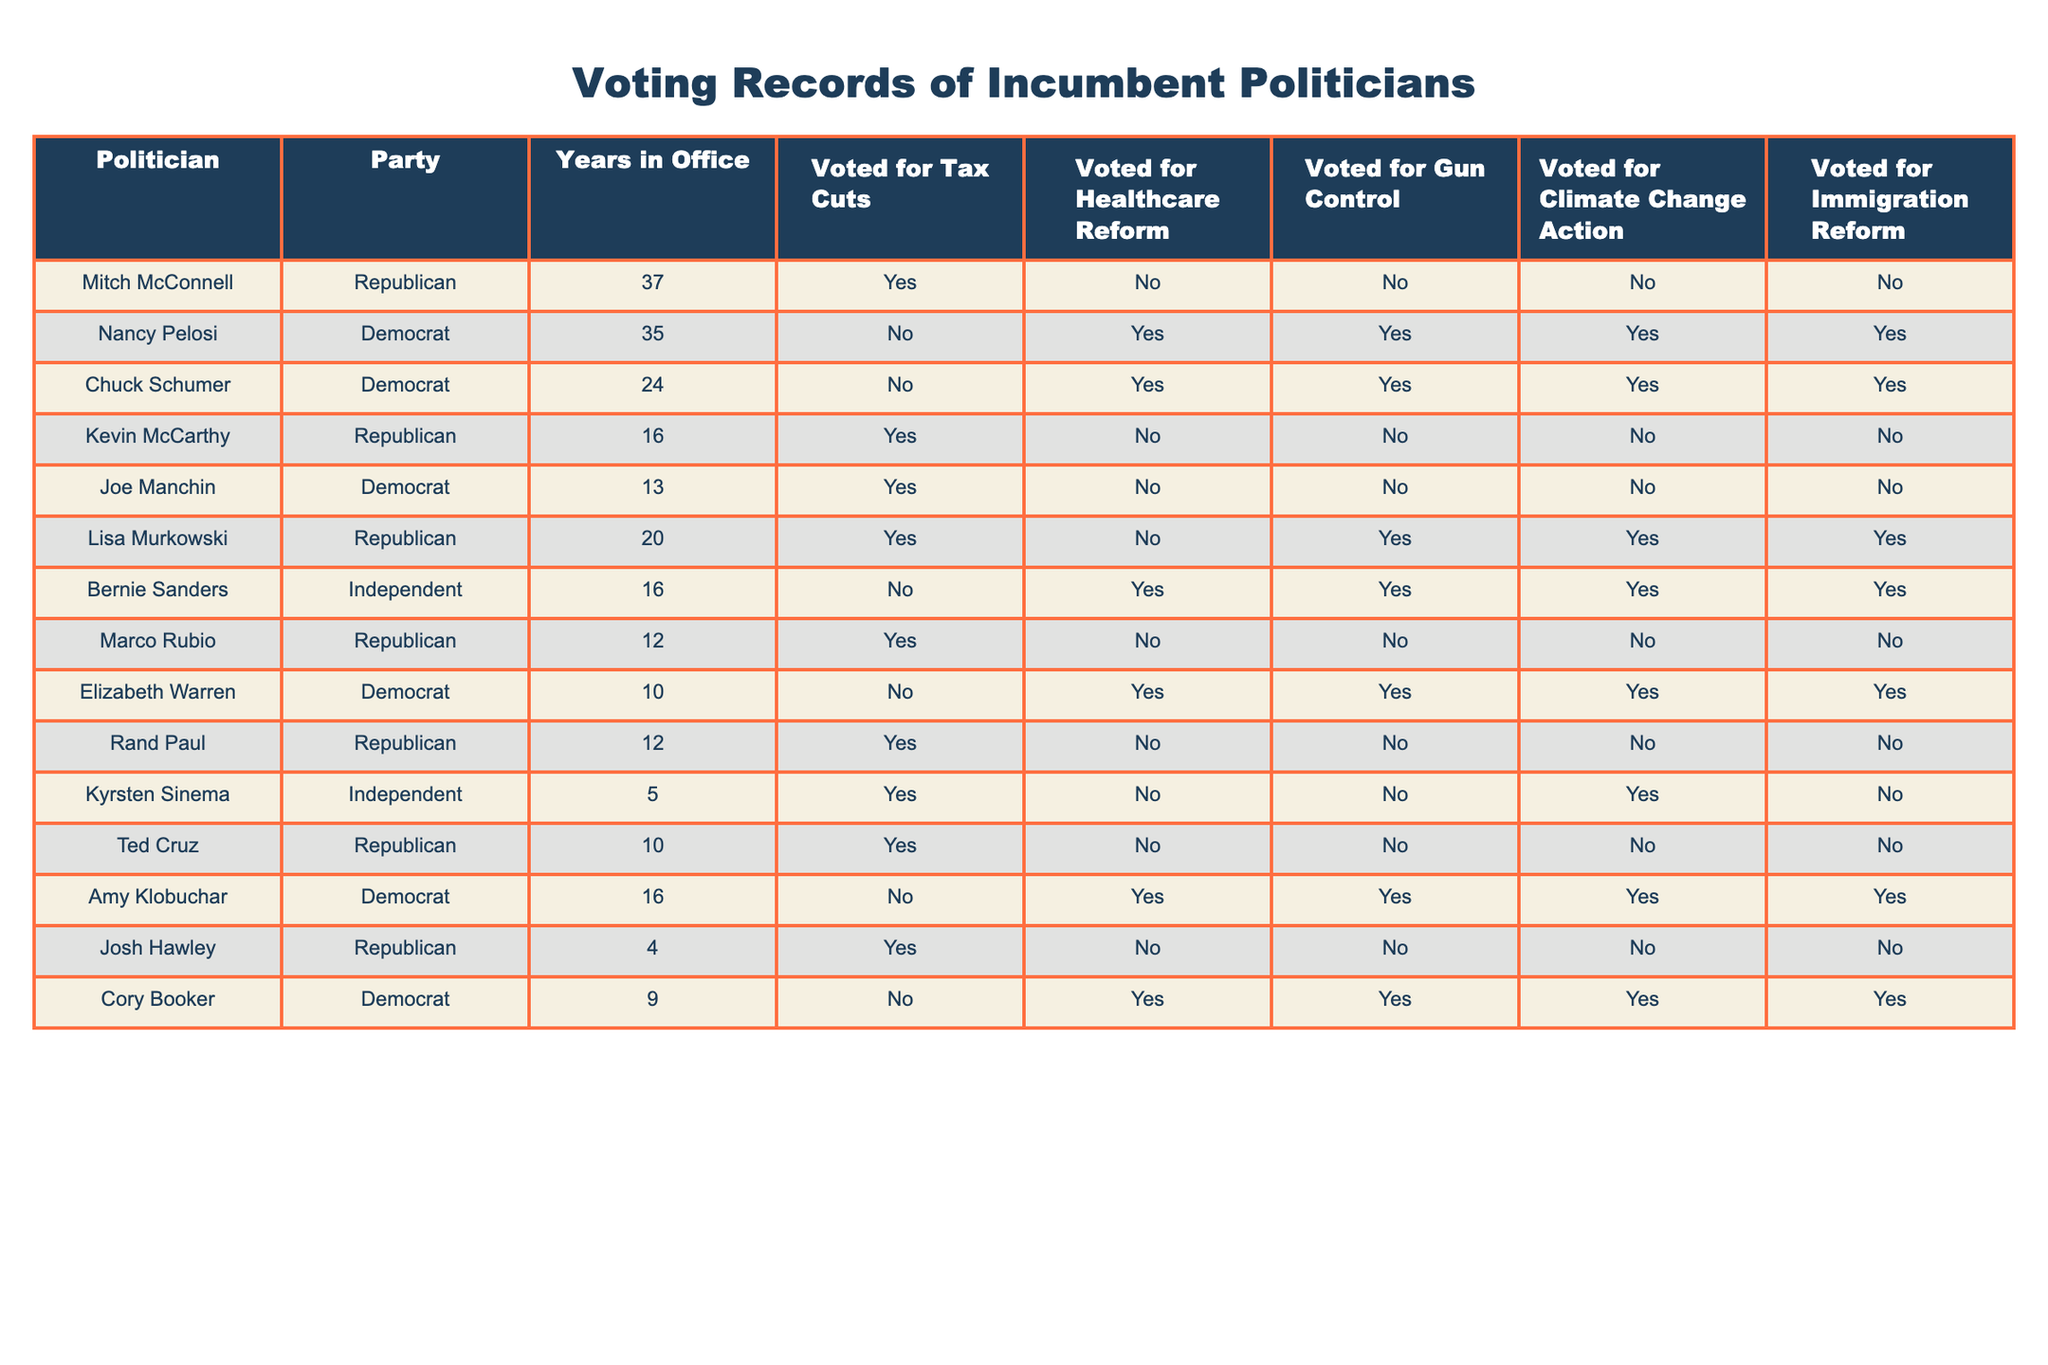What party does Bernie Sanders belong to? Bernie Sanders is listed in the "Party" column of the table. According to the data, he is categorized as an Independent.
Answer: Independent How many years has Nancy Pelosi been in office? By referring to the "Years in Office" column, we can see that Nancy Pelosi has served for 35 years.
Answer: 35 Did Joe Manchin vote for Healthcare Reform? Looking at the "Voted for Healthcare Reform" column for Joe Manchin, we see he voted "No."
Answer: No Which politician voted for Gun Control and Climate Change Action? We need to check the columns "Voted for Gun Control" and "Voted for Climate Change Action." By examining the table, we see that both Nancy Pelosi and Chuck Schumer voted "Yes" for both issues.
Answer: Nancy Pelosi and Chuck Schumer How many Republican politicians voted for Tax Cuts? From the "Voted for Tax Cuts" column, we count the number of "Yes" votes among Republican politicians: Mitch McConnell, Kevin McCarthy, Lisa Murkowski, Marco Rubio, Rand Paul, Ted Cruz, and Josh Hawley. This totals to 7 Republican politicians.
Answer: 7 Who has the longest time in office among Democrats? By checking the "Years in Office" column specifically for Democrats, Nancy Pelosi has served for 35 years, which is longer than any other Democrat in the table.
Answer: Nancy Pelosi Is there a politician who voted for both Gun Control and Immigration Reform? We analyze the "Voted for Gun Control" and "Voted for Immigration Reform" columns. The politicians who voted "Yes" for both are Nancy Pelosi, Chuck Schumer, Lisa Murkowski, Bernie Sanders, Elizabeth Warren, and Cory Booker.
Answer: Yes How many politicians voted "No" for Climate Change Action? We check the "Voted for Climate Change Action" column for "No" votes. Mitch McConnell, Kevin McCarthy, Joe Manchin, Marco Rubio, Rand Paul, Ted Cruz, and Josh Hawley each voted "No," totaling 7 politicians.
Answer: 7 What percentage of politicians voted for Immigration Reform? There are 14 total politicians. 6 of them voted "Yes" for Immigration Reform. To find the percentage, we calculate (6/14)*100, which equals approximately 42.86%.
Answer: 42.86% Which independent politician voted for the most key issues? Bernie Sanders voted "Yes" for Healthcare Reform, Gun Control, and Climate Change Action. Kyrsten Sinema voted "Yes" for Climate Change Action but "No" for the others. Thus, Bernie Sanders voted for more key issues.
Answer: Bernie Sanders 